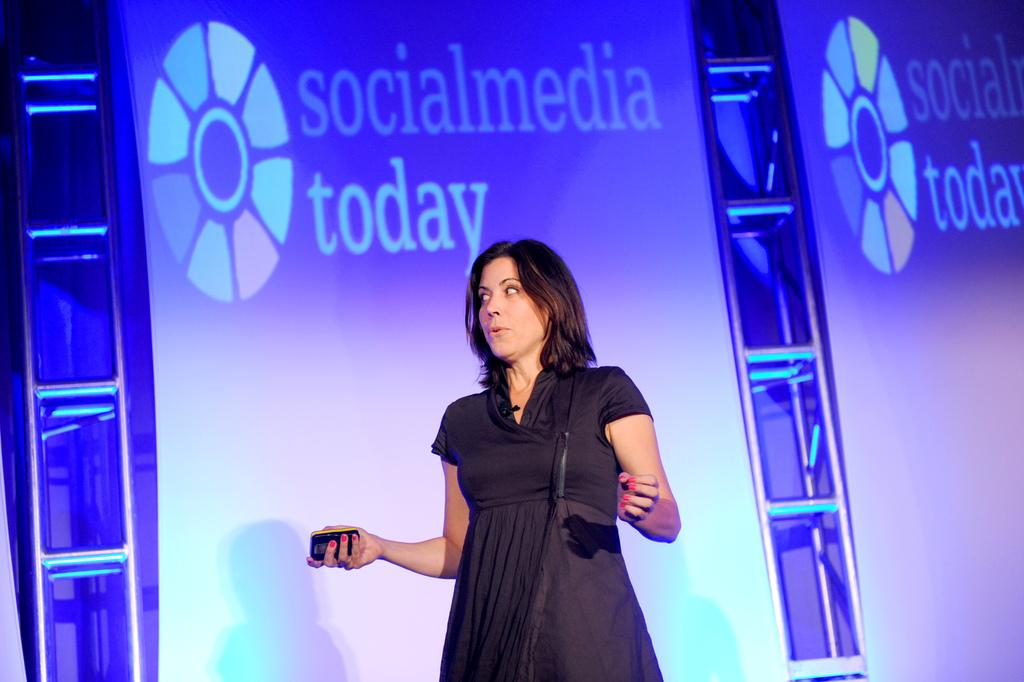What is the main subject of the image? The main subject of the image is a woman standing. What can be observed about the woman's attire? The woman is wearing clothes. What is the woman holding in her hand? The woman is holding a device in her hand. What can be seen behind the woman? There are ladders and a projected screen visible behind the woman. What is displayed on the projected screen? There is text on the projected screen. What type of canvas is the woman using to spy on her neighbors in the image? There is no canvas or spying activity present in the image. What flavor of mint can be seen in the woman's hand in the image? There is no mint visible in the image; the woman is holding a device. 